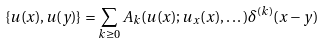<formula> <loc_0><loc_0><loc_500><loc_500>\{ u ( x ) , u ( y ) \} = \sum _ { k \geq 0 } A _ { k } ( u ( x ) ; u _ { x } ( x ) , \dots ) \delta ^ { ( k ) } ( x - y )</formula> 